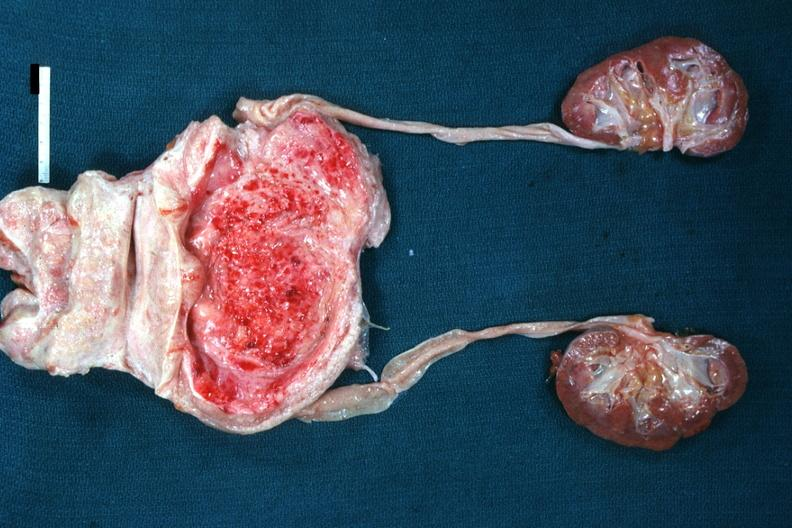what does this image show?
Answer the question using a single word or phrase. Enlarged nodular prostate with medial lobe enlargement bladder hypertrophy focal mucosal hemorrhages in bladder mild hydronephrosis very good example 